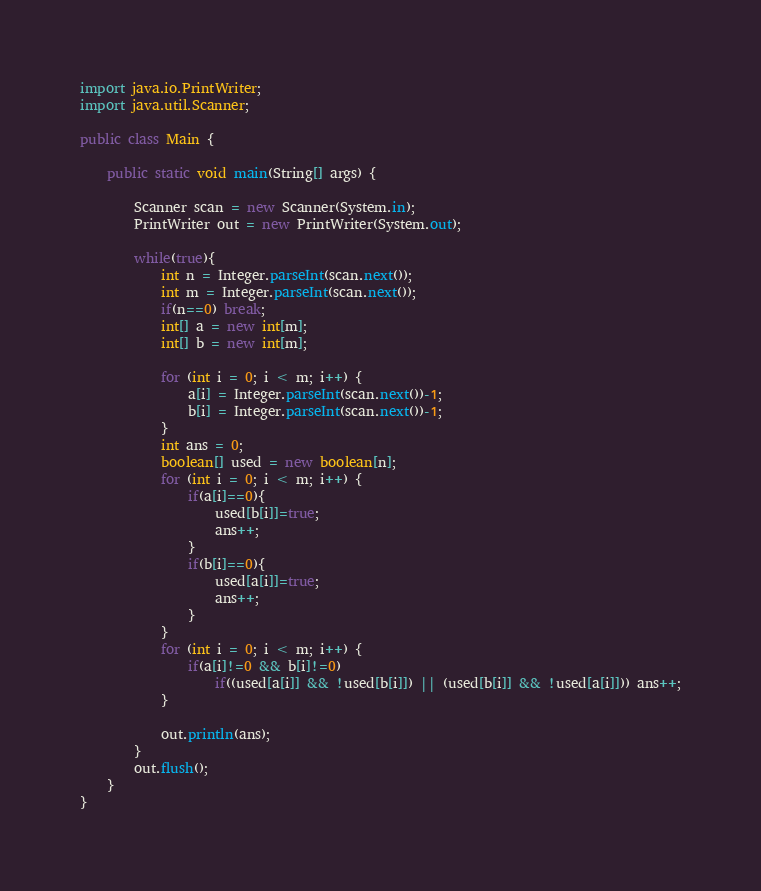Convert code to text. <code><loc_0><loc_0><loc_500><loc_500><_Java_>import java.io.PrintWriter;
import java.util.Scanner;

public class Main {

	public static void main(String[] args) {

		Scanner scan = new Scanner(System.in);
		PrintWriter out = new PrintWriter(System.out);

		while(true){
			int n = Integer.parseInt(scan.next());
			int m = Integer.parseInt(scan.next());
			if(n==0) break;
			int[] a = new int[m];
			int[] b = new int[m];

			for (int i = 0; i < m; i++) {
				a[i] = Integer.parseInt(scan.next())-1;
				b[i] = Integer.parseInt(scan.next())-1;
			}
			int ans = 0;
			boolean[] used = new boolean[n];
			for (int i = 0; i < m; i++) {
				if(a[i]==0){
					used[b[i]]=true;
					ans++;
				}
				if(b[i]==0){
					used[a[i]]=true;
					ans++;
				}
			}
			for (int i = 0; i < m; i++) {
				if(a[i]!=0 && b[i]!=0)
					if((used[a[i]] && !used[b[i]]) || (used[b[i]] && !used[a[i]])) ans++;
			}

			out.println(ans);
		}
		out.flush();
	}
}</code> 